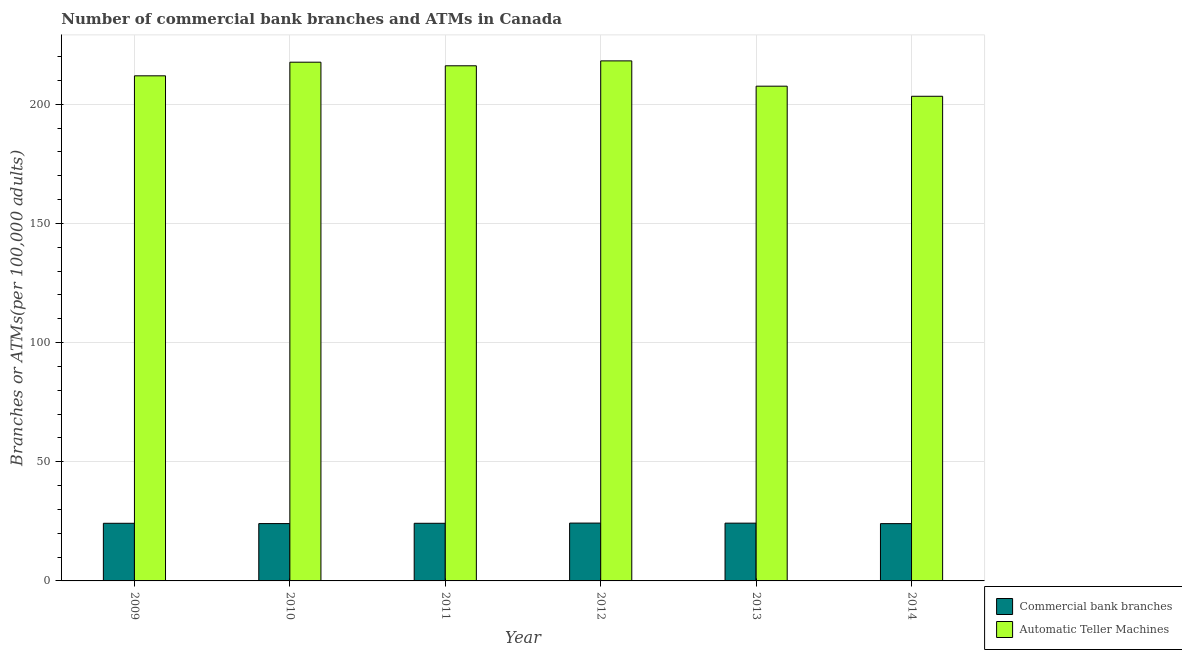How many groups of bars are there?
Make the answer very short. 6. How many bars are there on the 1st tick from the right?
Keep it short and to the point. 2. What is the label of the 2nd group of bars from the left?
Offer a very short reply. 2010. In how many cases, is the number of bars for a given year not equal to the number of legend labels?
Ensure brevity in your answer.  0. What is the number of atms in 2011?
Your response must be concise. 216.11. Across all years, what is the maximum number of commercal bank branches?
Keep it short and to the point. 24.27. Across all years, what is the minimum number of commercal bank branches?
Keep it short and to the point. 24.03. In which year was the number of atms maximum?
Your response must be concise. 2012. What is the total number of atms in the graph?
Your answer should be compact. 1274.72. What is the difference between the number of atms in 2013 and that in 2014?
Provide a short and direct response. 4.24. What is the difference between the number of commercal bank branches in 2010 and the number of atms in 2013?
Your response must be concise. -0.18. What is the average number of commercal bank branches per year?
Your answer should be very brief. 24.16. In the year 2014, what is the difference between the number of atms and number of commercal bank branches?
Provide a succinct answer. 0. In how many years, is the number of atms greater than 100?
Offer a terse response. 6. What is the ratio of the number of atms in 2010 to that in 2011?
Your answer should be compact. 1.01. What is the difference between the highest and the second highest number of atms?
Make the answer very short. 0.55. What is the difference between the highest and the lowest number of atms?
Provide a short and direct response. 14.85. Is the sum of the number of atms in 2011 and 2014 greater than the maximum number of commercal bank branches across all years?
Keep it short and to the point. Yes. What does the 1st bar from the left in 2013 represents?
Make the answer very short. Commercial bank branches. What does the 1st bar from the right in 2014 represents?
Ensure brevity in your answer.  Automatic Teller Machines. How many years are there in the graph?
Provide a succinct answer. 6. What is the difference between two consecutive major ticks on the Y-axis?
Your answer should be very brief. 50. Are the values on the major ticks of Y-axis written in scientific E-notation?
Provide a succinct answer. No. Does the graph contain any zero values?
Offer a terse response. No. What is the title of the graph?
Provide a short and direct response. Number of commercial bank branches and ATMs in Canada. What is the label or title of the X-axis?
Your answer should be very brief. Year. What is the label or title of the Y-axis?
Offer a very short reply. Branches or ATMs(per 100,0 adults). What is the Branches or ATMs(per 100,000 adults) of Commercial bank branches in 2009?
Provide a short and direct response. 24.18. What is the Branches or ATMs(per 100,000 adults) of Automatic Teller Machines in 2009?
Your response must be concise. 211.91. What is the Branches or ATMs(per 100,000 adults) in Commercial bank branches in 2010?
Your answer should be very brief. 24.05. What is the Branches or ATMs(per 100,000 adults) of Automatic Teller Machines in 2010?
Provide a succinct answer. 217.63. What is the Branches or ATMs(per 100,000 adults) of Commercial bank branches in 2011?
Ensure brevity in your answer.  24.18. What is the Branches or ATMs(per 100,000 adults) of Automatic Teller Machines in 2011?
Provide a short and direct response. 216.11. What is the Branches or ATMs(per 100,000 adults) in Commercial bank branches in 2012?
Your answer should be very brief. 24.27. What is the Branches or ATMs(per 100,000 adults) in Automatic Teller Machines in 2012?
Your response must be concise. 218.18. What is the Branches or ATMs(per 100,000 adults) in Commercial bank branches in 2013?
Your answer should be compact. 24.24. What is the Branches or ATMs(per 100,000 adults) in Automatic Teller Machines in 2013?
Give a very brief answer. 207.56. What is the Branches or ATMs(per 100,000 adults) of Commercial bank branches in 2014?
Provide a succinct answer. 24.03. What is the Branches or ATMs(per 100,000 adults) in Automatic Teller Machines in 2014?
Keep it short and to the point. 203.33. Across all years, what is the maximum Branches or ATMs(per 100,000 adults) of Commercial bank branches?
Provide a short and direct response. 24.27. Across all years, what is the maximum Branches or ATMs(per 100,000 adults) in Automatic Teller Machines?
Provide a short and direct response. 218.18. Across all years, what is the minimum Branches or ATMs(per 100,000 adults) of Commercial bank branches?
Offer a terse response. 24.03. Across all years, what is the minimum Branches or ATMs(per 100,000 adults) of Automatic Teller Machines?
Offer a terse response. 203.33. What is the total Branches or ATMs(per 100,000 adults) in Commercial bank branches in the graph?
Your answer should be very brief. 144.94. What is the total Branches or ATMs(per 100,000 adults) of Automatic Teller Machines in the graph?
Offer a very short reply. 1274.72. What is the difference between the Branches or ATMs(per 100,000 adults) of Commercial bank branches in 2009 and that in 2010?
Keep it short and to the point. 0.12. What is the difference between the Branches or ATMs(per 100,000 adults) of Automatic Teller Machines in 2009 and that in 2010?
Your response must be concise. -5.72. What is the difference between the Branches or ATMs(per 100,000 adults) of Commercial bank branches in 2009 and that in 2011?
Offer a terse response. 0. What is the difference between the Branches or ATMs(per 100,000 adults) in Automatic Teller Machines in 2009 and that in 2011?
Offer a terse response. -4.21. What is the difference between the Branches or ATMs(per 100,000 adults) of Commercial bank branches in 2009 and that in 2012?
Give a very brief answer. -0.09. What is the difference between the Branches or ATMs(per 100,000 adults) of Automatic Teller Machines in 2009 and that in 2012?
Provide a short and direct response. -6.27. What is the difference between the Branches or ATMs(per 100,000 adults) in Commercial bank branches in 2009 and that in 2013?
Your answer should be compact. -0.06. What is the difference between the Branches or ATMs(per 100,000 adults) of Automatic Teller Machines in 2009 and that in 2013?
Your answer should be very brief. 4.34. What is the difference between the Branches or ATMs(per 100,000 adults) in Commercial bank branches in 2009 and that in 2014?
Offer a terse response. 0.14. What is the difference between the Branches or ATMs(per 100,000 adults) of Automatic Teller Machines in 2009 and that in 2014?
Provide a short and direct response. 8.58. What is the difference between the Branches or ATMs(per 100,000 adults) of Commercial bank branches in 2010 and that in 2011?
Keep it short and to the point. -0.12. What is the difference between the Branches or ATMs(per 100,000 adults) of Automatic Teller Machines in 2010 and that in 2011?
Give a very brief answer. 1.51. What is the difference between the Branches or ATMs(per 100,000 adults) in Commercial bank branches in 2010 and that in 2012?
Provide a short and direct response. -0.21. What is the difference between the Branches or ATMs(per 100,000 adults) of Automatic Teller Machines in 2010 and that in 2012?
Your answer should be compact. -0.55. What is the difference between the Branches or ATMs(per 100,000 adults) in Commercial bank branches in 2010 and that in 2013?
Provide a succinct answer. -0.18. What is the difference between the Branches or ATMs(per 100,000 adults) in Automatic Teller Machines in 2010 and that in 2013?
Offer a very short reply. 10.06. What is the difference between the Branches or ATMs(per 100,000 adults) of Commercial bank branches in 2010 and that in 2014?
Provide a succinct answer. 0.02. What is the difference between the Branches or ATMs(per 100,000 adults) in Automatic Teller Machines in 2010 and that in 2014?
Your answer should be very brief. 14.3. What is the difference between the Branches or ATMs(per 100,000 adults) in Commercial bank branches in 2011 and that in 2012?
Make the answer very short. -0.09. What is the difference between the Branches or ATMs(per 100,000 adults) in Automatic Teller Machines in 2011 and that in 2012?
Offer a terse response. -2.06. What is the difference between the Branches or ATMs(per 100,000 adults) of Commercial bank branches in 2011 and that in 2013?
Make the answer very short. -0.06. What is the difference between the Branches or ATMs(per 100,000 adults) of Automatic Teller Machines in 2011 and that in 2013?
Offer a terse response. 8.55. What is the difference between the Branches or ATMs(per 100,000 adults) in Commercial bank branches in 2011 and that in 2014?
Make the answer very short. 0.14. What is the difference between the Branches or ATMs(per 100,000 adults) of Automatic Teller Machines in 2011 and that in 2014?
Keep it short and to the point. 12.79. What is the difference between the Branches or ATMs(per 100,000 adults) of Commercial bank branches in 2012 and that in 2013?
Your response must be concise. 0.03. What is the difference between the Branches or ATMs(per 100,000 adults) in Automatic Teller Machines in 2012 and that in 2013?
Provide a short and direct response. 10.61. What is the difference between the Branches or ATMs(per 100,000 adults) in Commercial bank branches in 2012 and that in 2014?
Offer a very short reply. 0.23. What is the difference between the Branches or ATMs(per 100,000 adults) of Automatic Teller Machines in 2012 and that in 2014?
Provide a short and direct response. 14.85. What is the difference between the Branches or ATMs(per 100,000 adults) of Commercial bank branches in 2013 and that in 2014?
Keep it short and to the point. 0.2. What is the difference between the Branches or ATMs(per 100,000 adults) of Automatic Teller Machines in 2013 and that in 2014?
Your answer should be very brief. 4.24. What is the difference between the Branches or ATMs(per 100,000 adults) of Commercial bank branches in 2009 and the Branches or ATMs(per 100,000 adults) of Automatic Teller Machines in 2010?
Provide a succinct answer. -193.45. What is the difference between the Branches or ATMs(per 100,000 adults) of Commercial bank branches in 2009 and the Branches or ATMs(per 100,000 adults) of Automatic Teller Machines in 2011?
Provide a short and direct response. -191.94. What is the difference between the Branches or ATMs(per 100,000 adults) in Commercial bank branches in 2009 and the Branches or ATMs(per 100,000 adults) in Automatic Teller Machines in 2012?
Give a very brief answer. -194. What is the difference between the Branches or ATMs(per 100,000 adults) of Commercial bank branches in 2009 and the Branches or ATMs(per 100,000 adults) of Automatic Teller Machines in 2013?
Offer a terse response. -183.39. What is the difference between the Branches or ATMs(per 100,000 adults) in Commercial bank branches in 2009 and the Branches or ATMs(per 100,000 adults) in Automatic Teller Machines in 2014?
Provide a short and direct response. -179.15. What is the difference between the Branches or ATMs(per 100,000 adults) in Commercial bank branches in 2010 and the Branches or ATMs(per 100,000 adults) in Automatic Teller Machines in 2011?
Offer a very short reply. -192.06. What is the difference between the Branches or ATMs(per 100,000 adults) in Commercial bank branches in 2010 and the Branches or ATMs(per 100,000 adults) in Automatic Teller Machines in 2012?
Your answer should be very brief. -194.12. What is the difference between the Branches or ATMs(per 100,000 adults) in Commercial bank branches in 2010 and the Branches or ATMs(per 100,000 adults) in Automatic Teller Machines in 2013?
Your answer should be very brief. -183.51. What is the difference between the Branches or ATMs(per 100,000 adults) in Commercial bank branches in 2010 and the Branches or ATMs(per 100,000 adults) in Automatic Teller Machines in 2014?
Provide a short and direct response. -179.27. What is the difference between the Branches or ATMs(per 100,000 adults) of Commercial bank branches in 2011 and the Branches or ATMs(per 100,000 adults) of Automatic Teller Machines in 2012?
Offer a terse response. -194. What is the difference between the Branches or ATMs(per 100,000 adults) of Commercial bank branches in 2011 and the Branches or ATMs(per 100,000 adults) of Automatic Teller Machines in 2013?
Your answer should be compact. -183.39. What is the difference between the Branches or ATMs(per 100,000 adults) of Commercial bank branches in 2011 and the Branches or ATMs(per 100,000 adults) of Automatic Teller Machines in 2014?
Provide a succinct answer. -179.15. What is the difference between the Branches or ATMs(per 100,000 adults) of Commercial bank branches in 2012 and the Branches or ATMs(per 100,000 adults) of Automatic Teller Machines in 2013?
Your answer should be very brief. -183.3. What is the difference between the Branches or ATMs(per 100,000 adults) in Commercial bank branches in 2012 and the Branches or ATMs(per 100,000 adults) in Automatic Teller Machines in 2014?
Offer a very short reply. -179.06. What is the difference between the Branches or ATMs(per 100,000 adults) in Commercial bank branches in 2013 and the Branches or ATMs(per 100,000 adults) in Automatic Teller Machines in 2014?
Offer a terse response. -179.09. What is the average Branches or ATMs(per 100,000 adults) of Commercial bank branches per year?
Offer a very short reply. 24.16. What is the average Branches or ATMs(per 100,000 adults) in Automatic Teller Machines per year?
Your answer should be very brief. 212.45. In the year 2009, what is the difference between the Branches or ATMs(per 100,000 adults) of Commercial bank branches and Branches or ATMs(per 100,000 adults) of Automatic Teller Machines?
Provide a succinct answer. -187.73. In the year 2010, what is the difference between the Branches or ATMs(per 100,000 adults) of Commercial bank branches and Branches or ATMs(per 100,000 adults) of Automatic Teller Machines?
Ensure brevity in your answer.  -193.57. In the year 2011, what is the difference between the Branches or ATMs(per 100,000 adults) in Commercial bank branches and Branches or ATMs(per 100,000 adults) in Automatic Teller Machines?
Ensure brevity in your answer.  -191.94. In the year 2012, what is the difference between the Branches or ATMs(per 100,000 adults) of Commercial bank branches and Branches or ATMs(per 100,000 adults) of Automatic Teller Machines?
Your response must be concise. -193.91. In the year 2013, what is the difference between the Branches or ATMs(per 100,000 adults) in Commercial bank branches and Branches or ATMs(per 100,000 adults) in Automatic Teller Machines?
Your response must be concise. -183.33. In the year 2014, what is the difference between the Branches or ATMs(per 100,000 adults) of Commercial bank branches and Branches or ATMs(per 100,000 adults) of Automatic Teller Machines?
Provide a succinct answer. -179.29. What is the ratio of the Branches or ATMs(per 100,000 adults) of Commercial bank branches in 2009 to that in 2010?
Your answer should be very brief. 1.01. What is the ratio of the Branches or ATMs(per 100,000 adults) in Automatic Teller Machines in 2009 to that in 2010?
Give a very brief answer. 0.97. What is the ratio of the Branches or ATMs(per 100,000 adults) in Commercial bank branches in 2009 to that in 2011?
Make the answer very short. 1. What is the ratio of the Branches or ATMs(per 100,000 adults) of Automatic Teller Machines in 2009 to that in 2011?
Ensure brevity in your answer.  0.98. What is the ratio of the Branches or ATMs(per 100,000 adults) of Commercial bank branches in 2009 to that in 2012?
Ensure brevity in your answer.  1. What is the ratio of the Branches or ATMs(per 100,000 adults) in Automatic Teller Machines in 2009 to that in 2012?
Offer a very short reply. 0.97. What is the ratio of the Branches or ATMs(per 100,000 adults) in Commercial bank branches in 2009 to that in 2013?
Your answer should be very brief. 1. What is the ratio of the Branches or ATMs(per 100,000 adults) in Automatic Teller Machines in 2009 to that in 2013?
Offer a terse response. 1.02. What is the ratio of the Branches or ATMs(per 100,000 adults) in Automatic Teller Machines in 2009 to that in 2014?
Make the answer very short. 1.04. What is the ratio of the Branches or ATMs(per 100,000 adults) in Commercial bank branches in 2010 to that in 2012?
Offer a terse response. 0.99. What is the ratio of the Branches or ATMs(per 100,000 adults) in Commercial bank branches in 2010 to that in 2013?
Ensure brevity in your answer.  0.99. What is the ratio of the Branches or ATMs(per 100,000 adults) of Automatic Teller Machines in 2010 to that in 2013?
Offer a terse response. 1.05. What is the ratio of the Branches or ATMs(per 100,000 adults) in Commercial bank branches in 2010 to that in 2014?
Keep it short and to the point. 1. What is the ratio of the Branches or ATMs(per 100,000 adults) of Automatic Teller Machines in 2010 to that in 2014?
Keep it short and to the point. 1.07. What is the ratio of the Branches or ATMs(per 100,000 adults) of Automatic Teller Machines in 2011 to that in 2012?
Provide a succinct answer. 0.99. What is the ratio of the Branches or ATMs(per 100,000 adults) of Automatic Teller Machines in 2011 to that in 2013?
Your answer should be compact. 1.04. What is the ratio of the Branches or ATMs(per 100,000 adults) of Commercial bank branches in 2011 to that in 2014?
Keep it short and to the point. 1.01. What is the ratio of the Branches or ATMs(per 100,000 adults) of Automatic Teller Machines in 2011 to that in 2014?
Provide a succinct answer. 1.06. What is the ratio of the Branches or ATMs(per 100,000 adults) of Automatic Teller Machines in 2012 to that in 2013?
Your answer should be very brief. 1.05. What is the ratio of the Branches or ATMs(per 100,000 adults) in Commercial bank branches in 2012 to that in 2014?
Offer a terse response. 1.01. What is the ratio of the Branches or ATMs(per 100,000 adults) of Automatic Teller Machines in 2012 to that in 2014?
Keep it short and to the point. 1.07. What is the ratio of the Branches or ATMs(per 100,000 adults) of Commercial bank branches in 2013 to that in 2014?
Give a very brief answer. 1.01. What is the ratio of the Branches or ATMs(per 100,000 adults) in Automatic Teller Machines in 2013 to that in 2014?
Your response must be concise. 1.02. What is the difference between the highest and the second highest Branches or ATMs(per 100,000 adults) of Commercial bank branches?
Provide a short and direct response. 0.03. What is the difference between the highest and the second highest Branches or ATMs(per 100,000 adults) of Automatic Teller Machines?
Your response must be concise. 0.55. What is the difference between the highest and the lowest Branches or ATMs(per 100,000 adults) of Commercial bank branches?
Give a very brief answer. 0.23. What is the difference between the highest and the lowest Branches or ATMs(per 100,000 adults) of Automatic Teller Machines?
Provide a short and direct response. 14.85. 